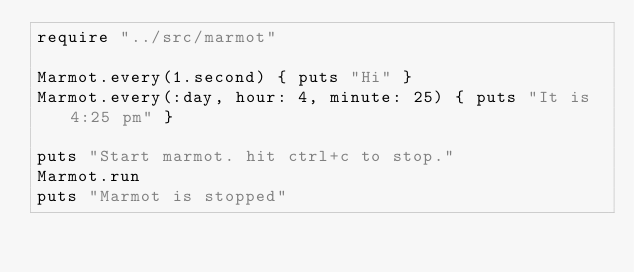<code> <loc_0><loc_0><loc_500><loc_500><_Crystal_>require "../src/marmot"

Marmot.every(1.second) { puts "Hi" }
Marmot.every(:day, hour: 4, minute: 25) { puts "It is 4:25 pm" }

puts "Start marmot. hit ctrl+c to stop."
Marmot.run
puts "Marmot is stopped"
</code> 